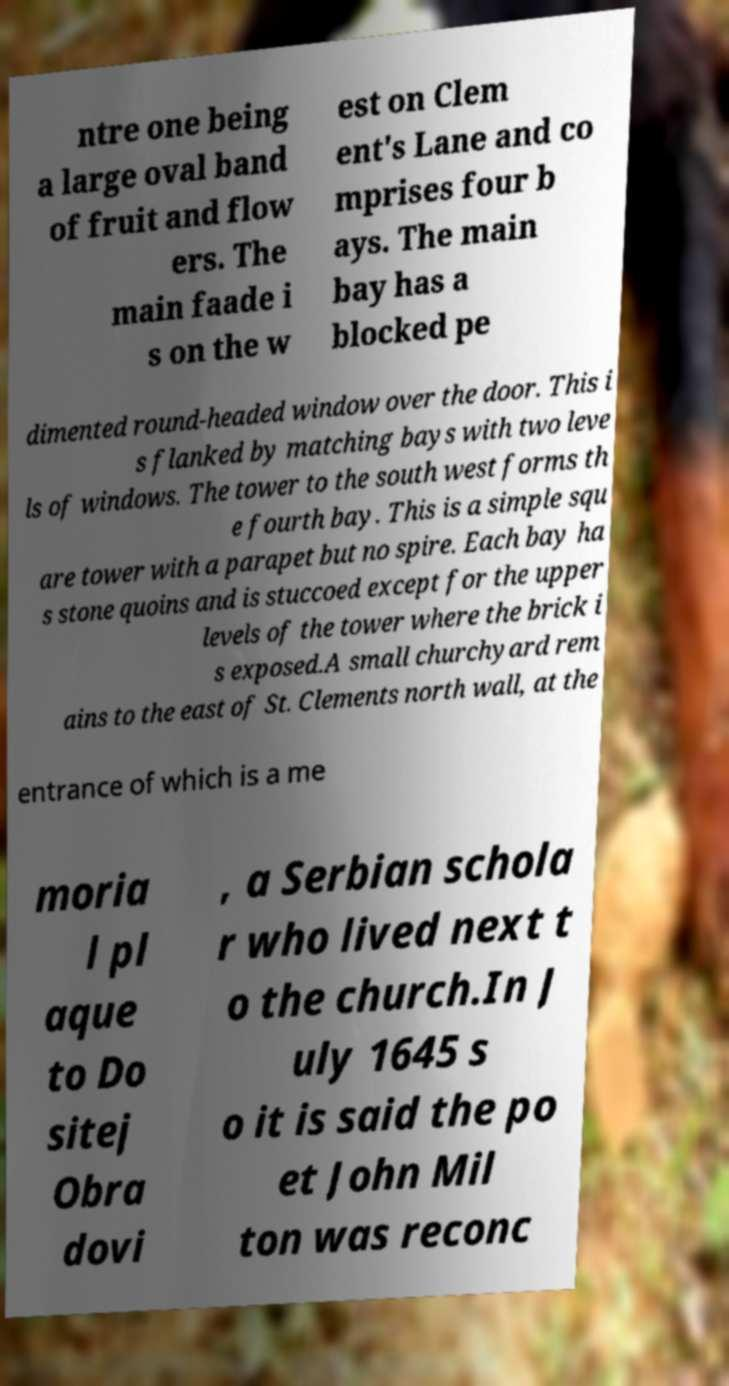Could you extract and type out the text from this image? ntre one being a large oval band of fruit and flow ers. The main faade i s on the w est on Clem ent's Lane and co mprises four b ays. The main bay has a blocked pe dimented round-headed window over the door. This i s flanked by matching bays with two leve ls of windows. The tower to the south west forms th e fourth bay. This is a simple squ are tower with a parapet but no spire. Each bay ha s stone quoins and is stuccoed except for the upper levels of the tower where the brick i s exposed.A small churchyard rem ains to the east of St. Clements north wall, at the entrance of which is a me moria l pl aque to Do sitej Obra dovi , a Serbian schola r who lived next t o the church.In J uly 1645 s o it is said the po et John Mil ton was reconc 